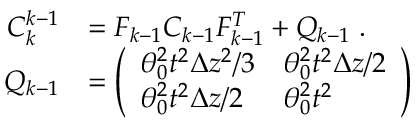<formula> <loc_0><loc_0><loc_500><loc_500>\begin{array} { r l } { C _ { k } ^ { k - 1 } } & { = F _ { k - 1 } C _ { k - 1 } F _ { k - 1 } ^ { T } + Q _ { k - 1 } \, . } \\ { Q _ { k - 1 } } & { = \left ( \begin{array} { l l } { \theta _ { 0 } ^ { 2 } t ^ { 2 } \Delta z ^ { 2 } / 3 } & { \theta _ { 0 } ^ { 2 } t ^ { 2 } \Delta z / 2 } \\ { \theta _ { 0 } ^ { 2 } t ^ { 2 } \Delta z / 2 } & { \theta _ { 0 } ^ { 2 } t ^ { 2 } } \end{array} \right ) } \end{array}</formula> 